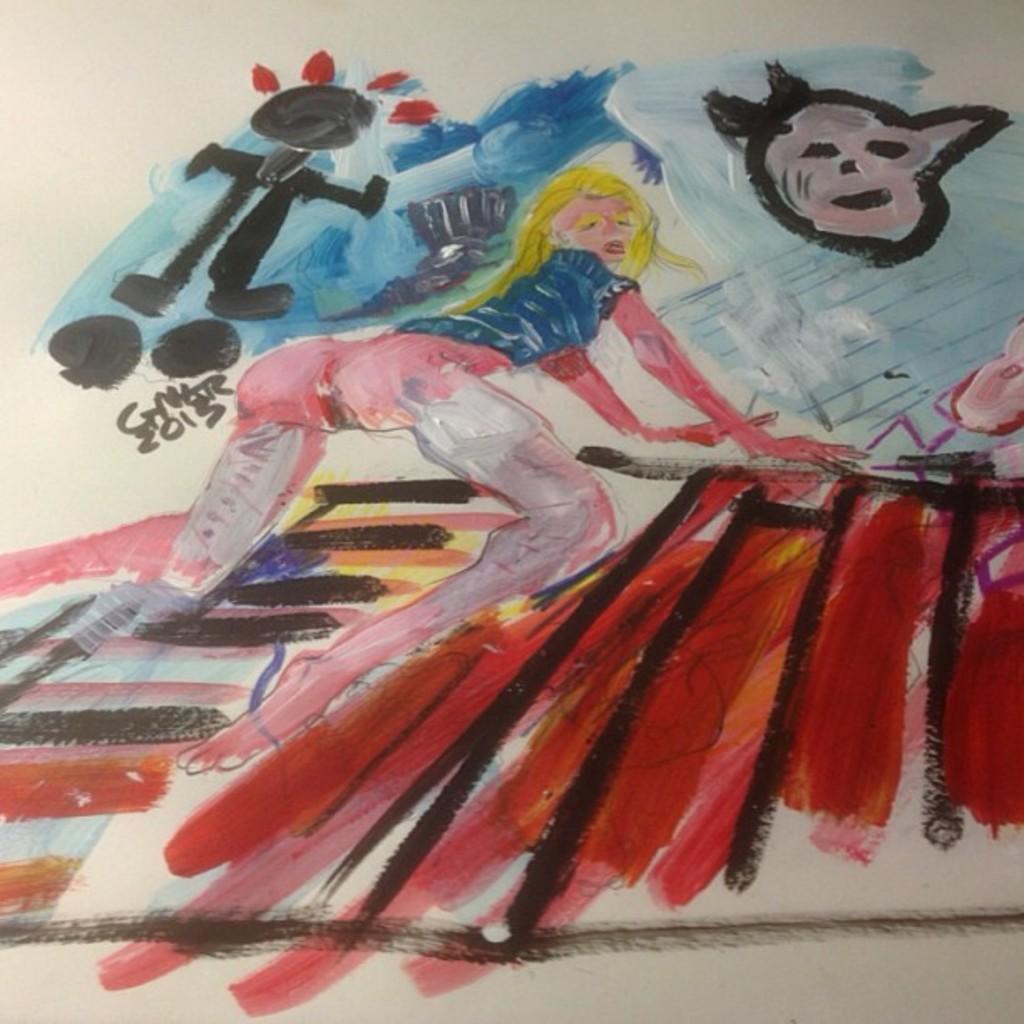Please provide a concise description of this image. In this picture we can see a drawing on a paper with different colors. 